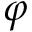Convert formula to latex. <formula><loc_0><loc_0><loc_500><loc_500>\varphi</formula> 